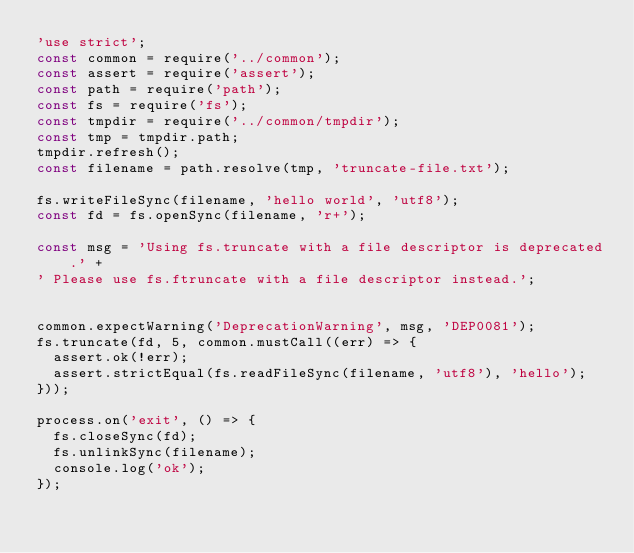Convert code to text. <code><loc_0><loc_0><loc_500><loc_500><_JavaScript_>'use strict';
const common = require('../common');
const assert = require('assert');
const path = require('path');
const fs = require('fs');
const tmpdir = require('../common/tmpdir');
const tmp = tmpdir.path;
tmpdir.refresh();
const filename = path.resolve(tmp, 'truncate-file.txt');

fs.writeFileSync(filename, 'hello world', 'utf8');
const fd = fs.openSync(filename, 'r+');

const msg = 'Using fs.truncate with a file descriptor is deprecated.' +
' Please use fs.ftruncate with a file descriptor instead.';


common.expectWarning('DeprecationWarning', msg, 'DEP0081');
fs.truncate(fd, 5, common.mustCall((err) => {
  assert.ok(!err);
  assert.strictEqual(fs.readFileSync(filename, 'utf8'), 'hello');
}));

process.on('exit', () => {
  fs.closeSync(fd);
  fs.unlinkSync(filename);
  console.log('ok');
});
</code> 